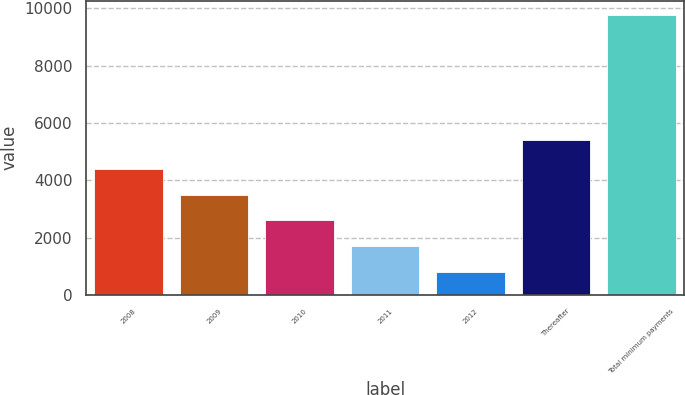Convert chart to OTSL. <chart><loc_0><loc_0><loc_500><loc_500><bar_chart><fcel>2008<fcel>2009<fcel>2010<fcel>2011<fcel>2012<fcel>Thereafter<fcel>Total minimum payments<nl><fcel>4395.68<fcel>3499.01<fcel>2602.34<fcel>1705.67<fcel>809<fcel>5414.8<fcel>9775.7<nl></chart> 